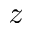Convert formula to latex. <formula><loc_0><loc_0><loc_500><loc_500>z</formula> 